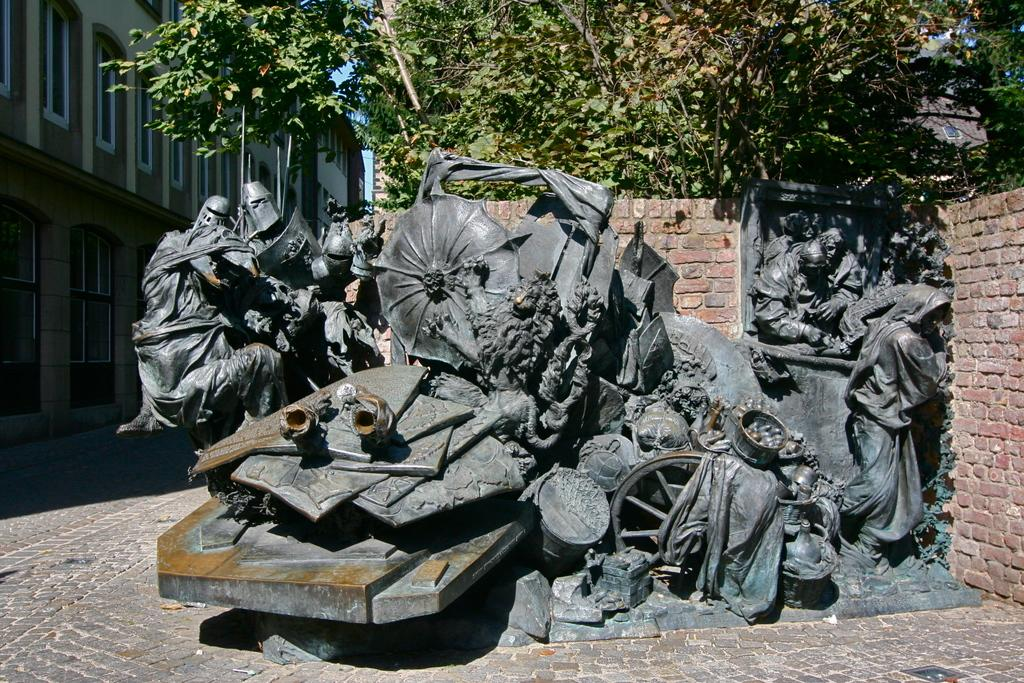What can be seen on the surface in the image? There are statues on the surface in the image. What type of structure is present in the image? There is a brick wall in the image. What type of vegetation is present in the image? There are trees in the image. What type of structures are visible on the left side of the image? Buildings with walls and windows are visible on the left side of the image. How does the comparison between the statues and bushes affect the overall aesthetic of the image? There are no bushes mentioned in the image, so it's not possible to make a comparison between the statues and bushes. 